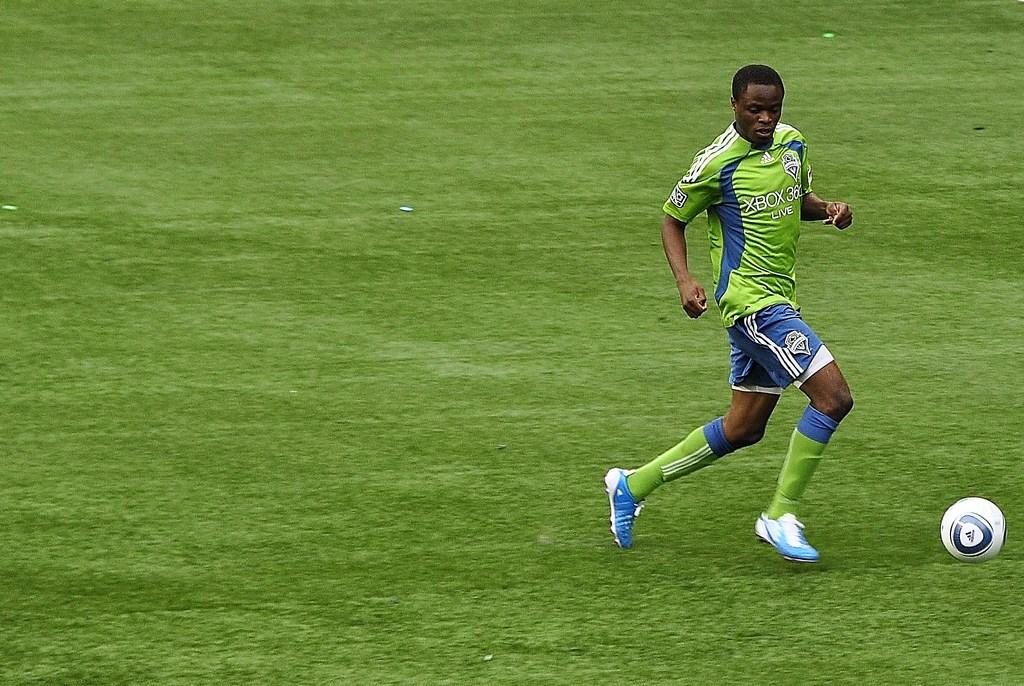<image>
Create a compact narrative representing the image presented. A soccer player in a green Xbox 360 shirt. 